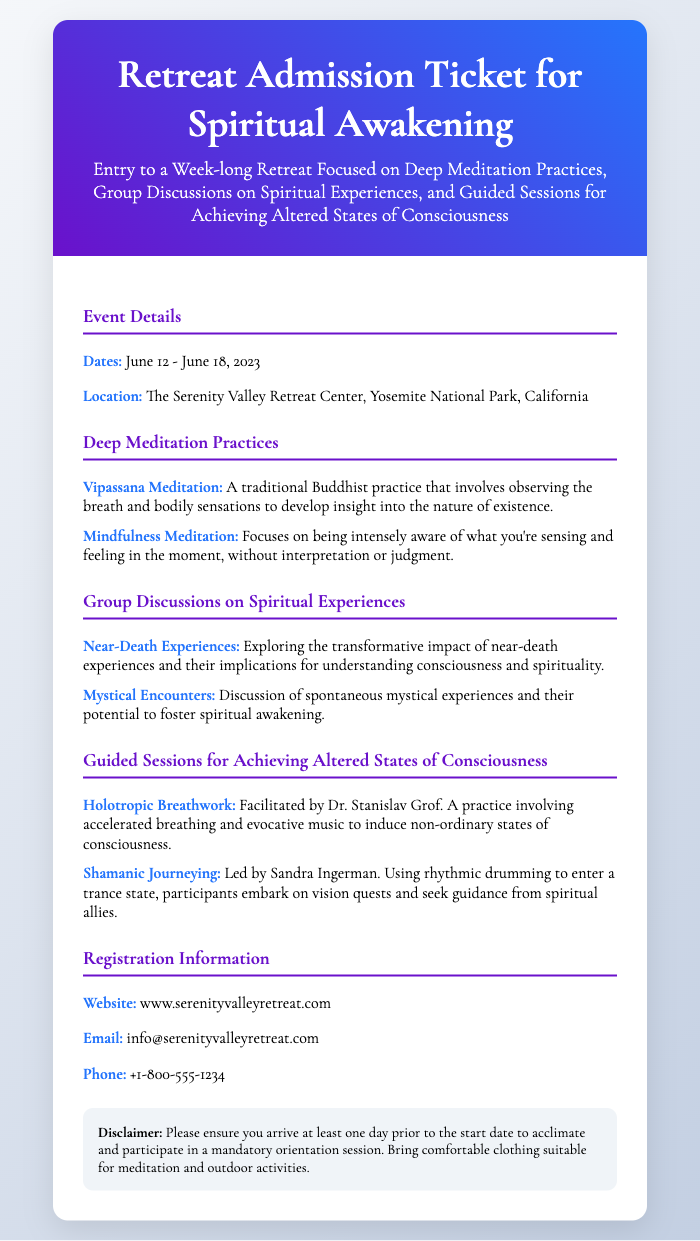What are the dates of the retreat? The dates of the retreat are clearly specified in the document.
Answer: June 12 - June 18, 2023 Where is the retreat located? The location of the retreat is mentioned in the event details section of the document.
Answer: The Serenity Valley Retreat Center, Yosemite National Park, California Who facilitates the Holotropic Breathwork session? The document provides specific information about the facilitators of the sessions.
Answer: Dr. Stanislav Grof What is one type of meditation practiced at the retreat? The document lists meditation practices, where one can be identified as an example.
Answer: Vipassana Meditation What should participants bring for the retreat? The disclaimer section of the document outlines necessary items participants should prepare.
Answer: Comfortable clothing suitable for meditation and outdoor activities How can one contact the retreat center? The registration information provides explicit contact details for inquiries.
Answer: info@serenityvalleyretreat.com What is the website for registration? The registration information section clearly states the website for further details.
Answer: www.serenityvalleyretreat.com What type of altered state of consciousness practice is led by Sandra Ingerman? The guide's name and the type of practice they conduct is listed in the document.
Answer: Shamanic Journeying 